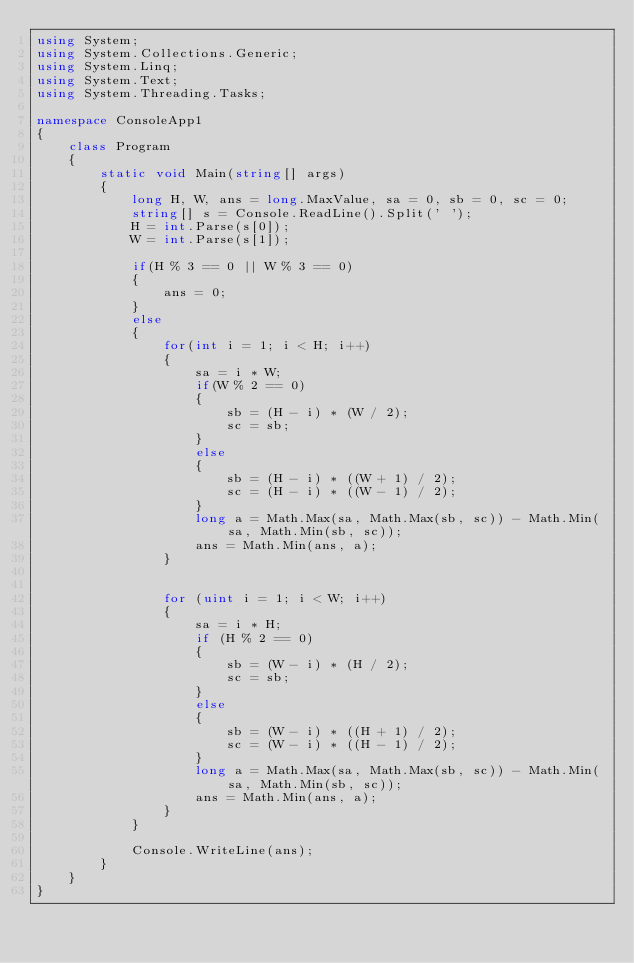<code> <loc_0><loc_0><loc_500><loc_500><_C#_>using System;
using System.Collections.Generic;
using System.Linq;
using System.Text;
using System.Threading.Tasks;

namespace ConsoleApp1
{
    class Program
    {
        static void Main(string[] args)
        {
            long H, W, ans = long.MaxValue, sa = 0, sb = 0, sc = 0;
            string[] s = Console.ReadLine().Split(' ');
            H = int.Parse(s[0]);
            W = int.Parse(s[1]);

            if(H % 3 == 0 || W % 3 == 0)
            {
                ans = 0;
            }
            else
            {
                for(int i = 1; i < H; i++)
                {
                    sa = i * W;
                    if(W % 2 == 0)
                    {
                        sb = (H - i) * (W / 2);
                        sc = sb;
                    }
                    else
                    {
                        sb = (H - i) * ((W + 1) / 2);
                        sc = (H - i) * ((W - 1) / 2);
                    }
                    long a = Math.Max(sa, Math.Max(sb, sc)) - Math.Min(sa, Math.Min(sb, sc));
                    ans = Math.Min(ans, a);
                }


                for (uint i = 1; i < W; i++)
                {
                    sa = i * H;
                    if (H % 2 == 0)
                    {
                        sb = (W - i) * (H / 2);
                        sc = sb;
                    }
                    else
                    {
                        sb = (W - i) * ((H + 1) / 2);
                        sc = (W - i) * ((H - 1) / 2);
                    }
                    long a = Math.Max(sa, Math.Max(sb, sc)) - Math.Min(sa, Math.Min(sb, sc));
                    ans = Math.Min(ans, a);
                }
            }

            Console.WriteLine(ans);
        }
    }
}
</code> 